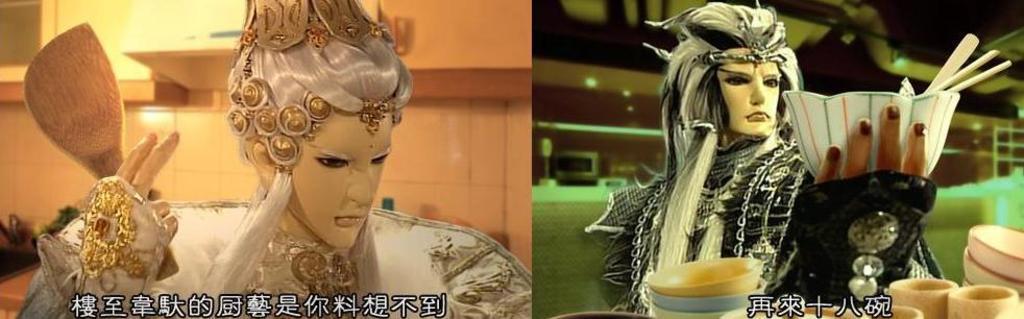Can you describe this image briefly? As we can see in the image there are two people. The person on the left side is wearing white color dress and on the left side there are tiles. On the right side there is a table and a person wearing black color dress. On tail there are plates and bowls. 